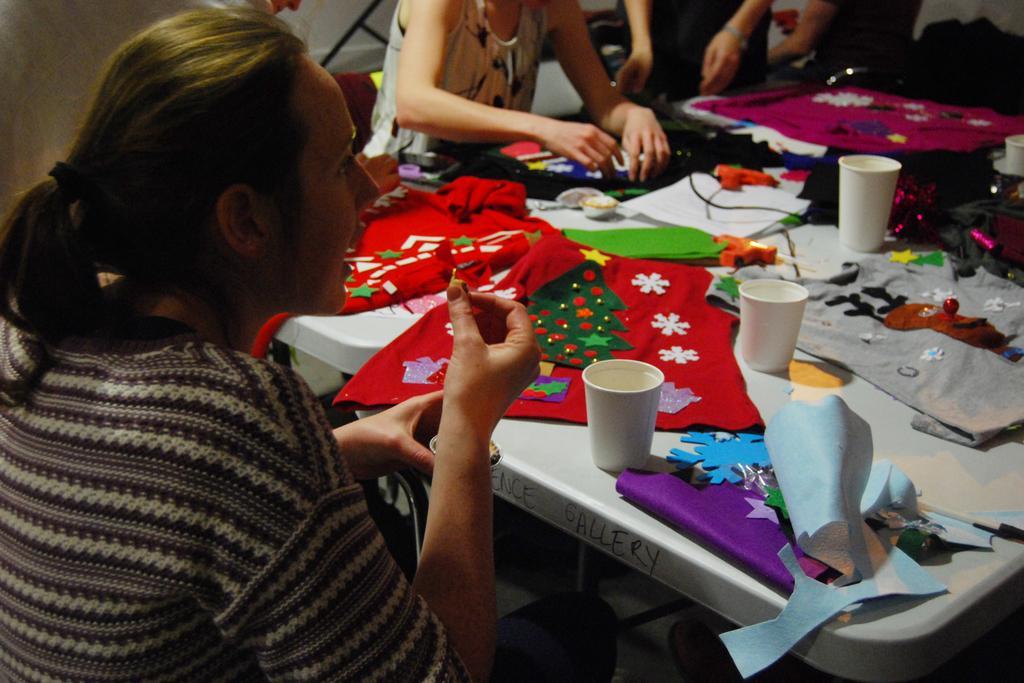In one or two sentences, can you explain what this image depicts? In this picture we can see some people sitting on chair and in front of them there is table and on table we can see clothes, glasses and stitching materials. 